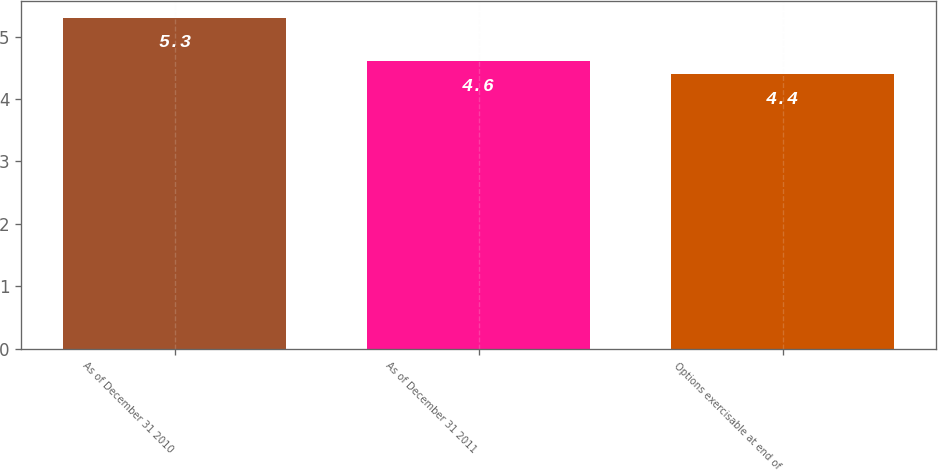Convert chart to OTSL. <chart><loc_0><loc_0><loc_500><loc_500><bar_chart><fcel>As of December 31 2010<fcel>As of December 31 2011<fcel>Options exercisable at end of<nl><fcel>5.3<fcel>4.6<fcel>4.4<nl></chart> 